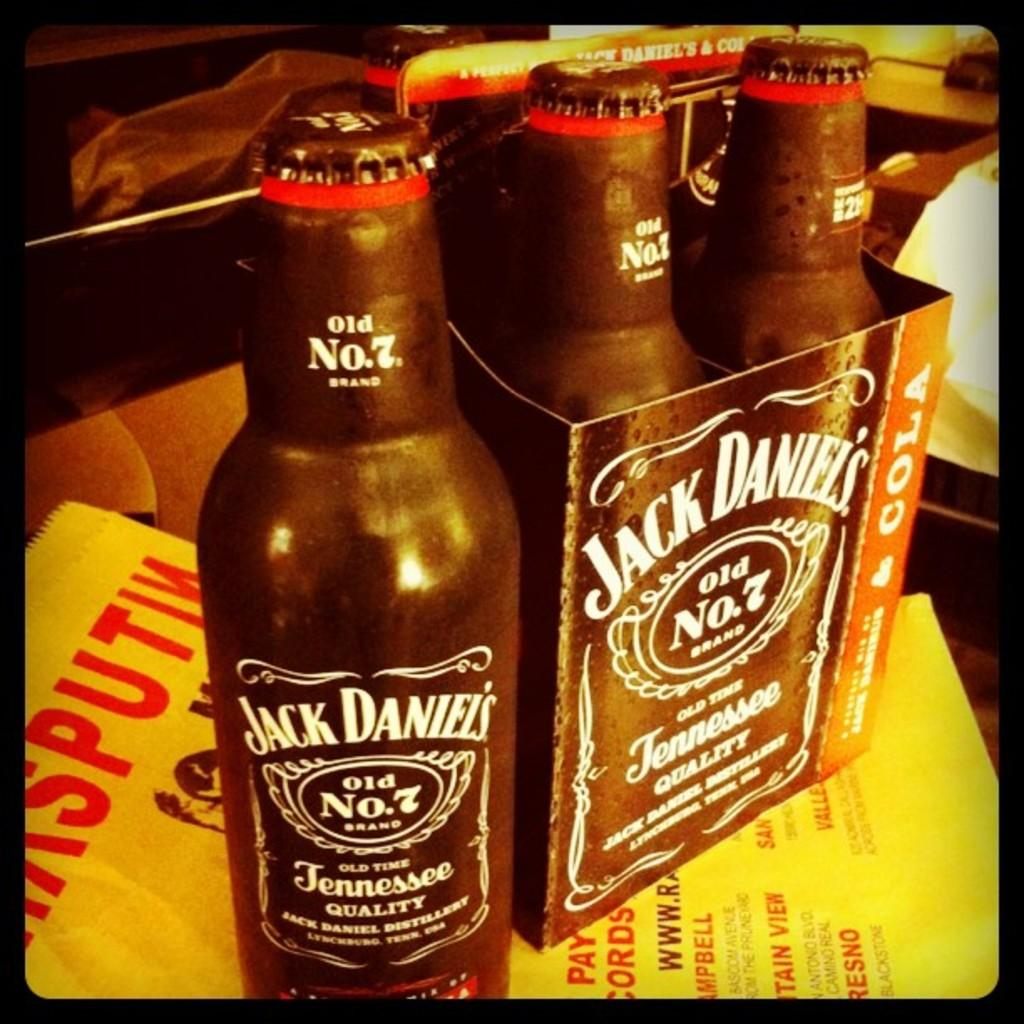<image>
Render a clear and concise summary of the photo. the words Jack Daniels that are on some bottles 